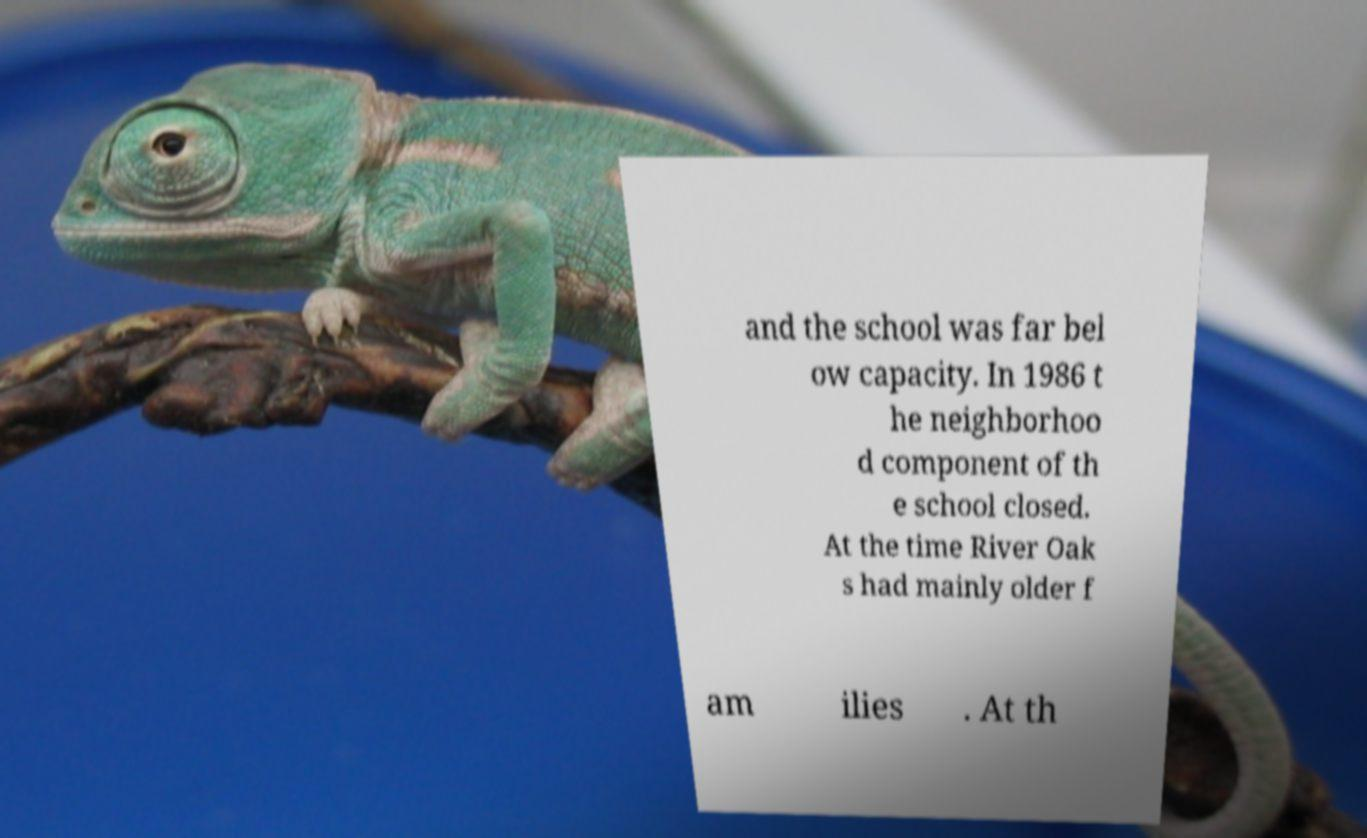There's text embedded in this image that I need extracted. Can you transcribe it verbatim? and the school was far bel ow capacity. In 1986 t he neighborhoo d component of th e school closed. At the time River Oak s had mainly older f am ilies . At th 